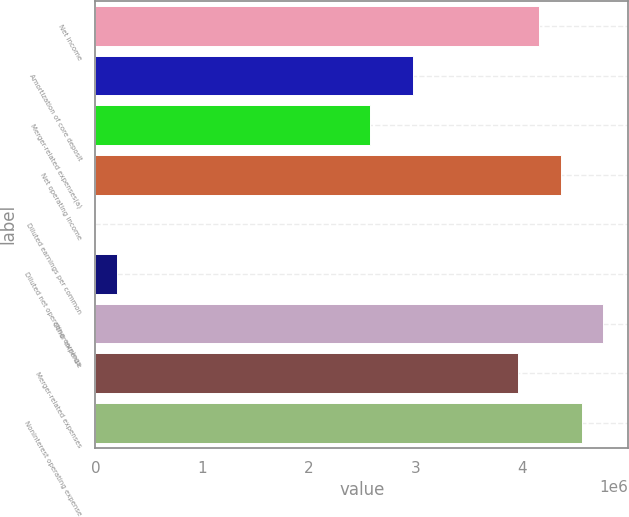Convert chart to OTSL. <chart><loc_0><loc_0><loc_500><loc_500><bar_chart><fcel>Net income<fcel>Amortization of core deposit<fcel>Merger-related expenses(a)<fcel>Net operating income<fcel>Diluted earnings per common<fcel>Diluted net operating earnings<fcel>Other expense<fcel>Merger-related expenses<fcel>Noninterest operating expense<nl><fcel>4.15918e+06<fcel>2.97084e+06<fcel>2.57473e+06<fcel>4.35724e+06<fcel>2.89<fcel>198059<fcel>4.75335e+06<fcel>3.96112e+06<fcel>4.55529e+06<nl></chart> 